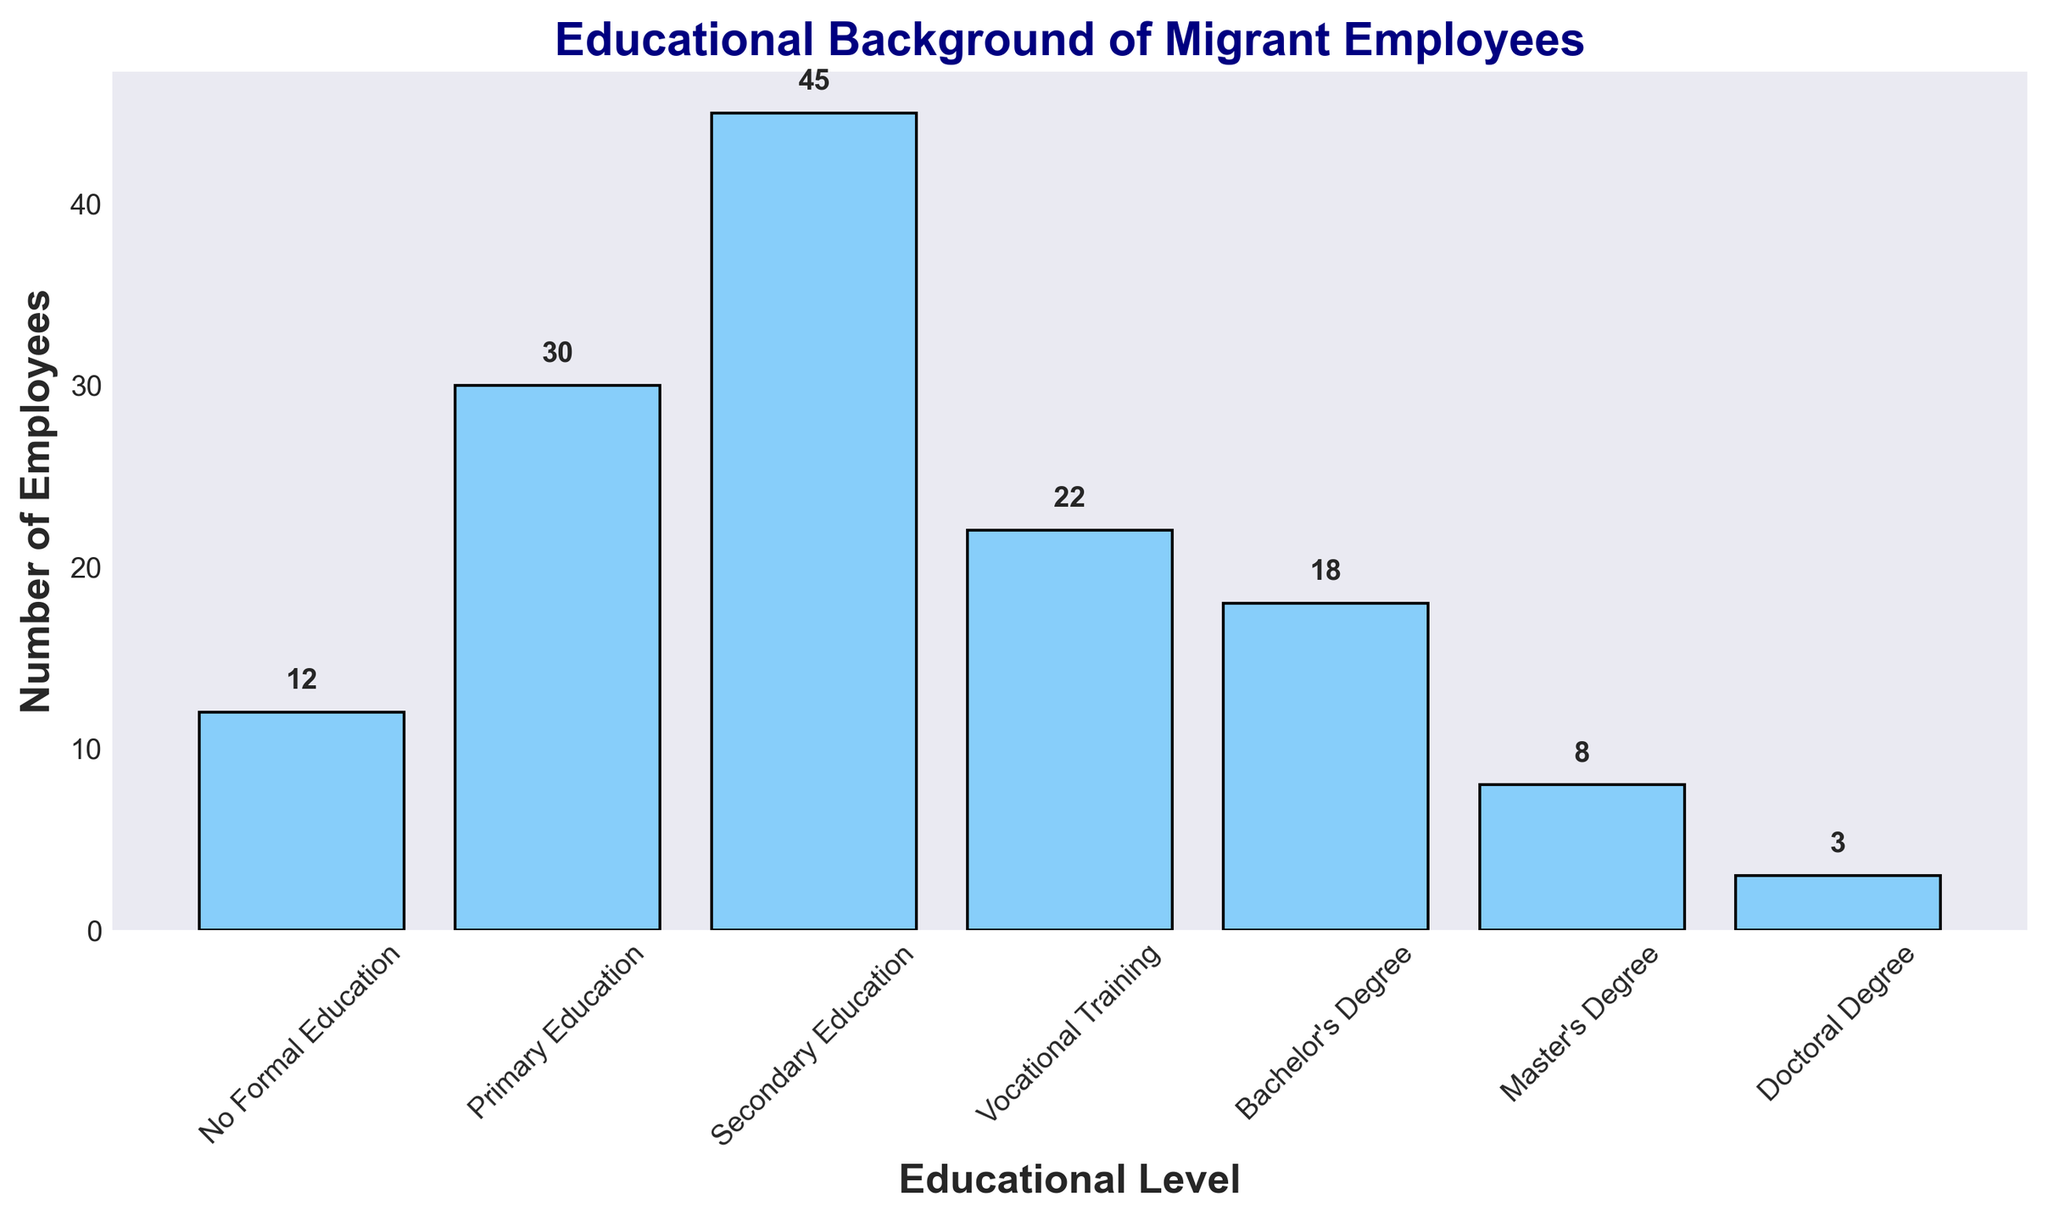How many employees have a Bachelor's Degree? The number of employees with a Bachelor’s Degree can be read directly from the bar corresponding to that educational level. The bar's height and the number label on top of it indicate 18 employees.
Answer: 18 Which educational level has the highest number of migrant employees? By visually comparing the heights of all bars, the tallest bar corresponds to Secondary Education. The label on top of this bar confirms it has 45 employees.
Answer: Secondary Education What is the total number of migrant employees with at least a Bachelor's Degree? Sum the numbers of employees with Bachelor's, Master's, and Doctoral degrees: 18 (Bachelor's) + 8 (Master's) + 3 (Doctoral) = 29.
Answer: 29 How does the number of employees with Primary Education compare to those with Vocational Training? For comparison, check the heights of the corresponding bars. Primary Education has 30 employees, while Vocational Training has 22 employees. Since 30 is greater than 22, there are more employees with Primary Education.
Answer: Primary Education is greater What percentage of the employees have Secondary Education? To find the percentage, divide the number of employees with Secondary Education (45) by the total number of employees (12+30+45+22+18+8+3 = 138), then multiply by 100: (45 / 138) * 100 ≈ 32.61%.
Answer: 32.61% What is the combined number of employees with No Formal Education and Primary Education? Add the number of employees with No Formal Education (12) and Primary Education (30): 12 + 30 = 42.
Answer: 42 What educational level has the least number of migrant employees? Visually, the shortest bar corresponds to the Doctoral Degree. The label on top also confirms there are only 3 employees with a Doctoral Degree.
Answer: Doctoral Degree How does the number of employees with Vocational Training compare to those with Master’s Degrees? Compare the heights of the Vocational Training and Master’s Degree bars. Vocational Training has 22 employees, while Master’s Degrees has 8 employees. The difference is 22 - 8 = 14, indicating there are 14 more employees with Vocational Training.
Answer: 14 more with Vocational Training What is the average number of employees across all educational levels? Add the number of employees across all educational levels and then divide by the number of levels: (12 + 30 + 45 + 22 + 18 + 8 + 3) / 7 = 138 / 7 ≈ 19.71.
Answer: 19.71 